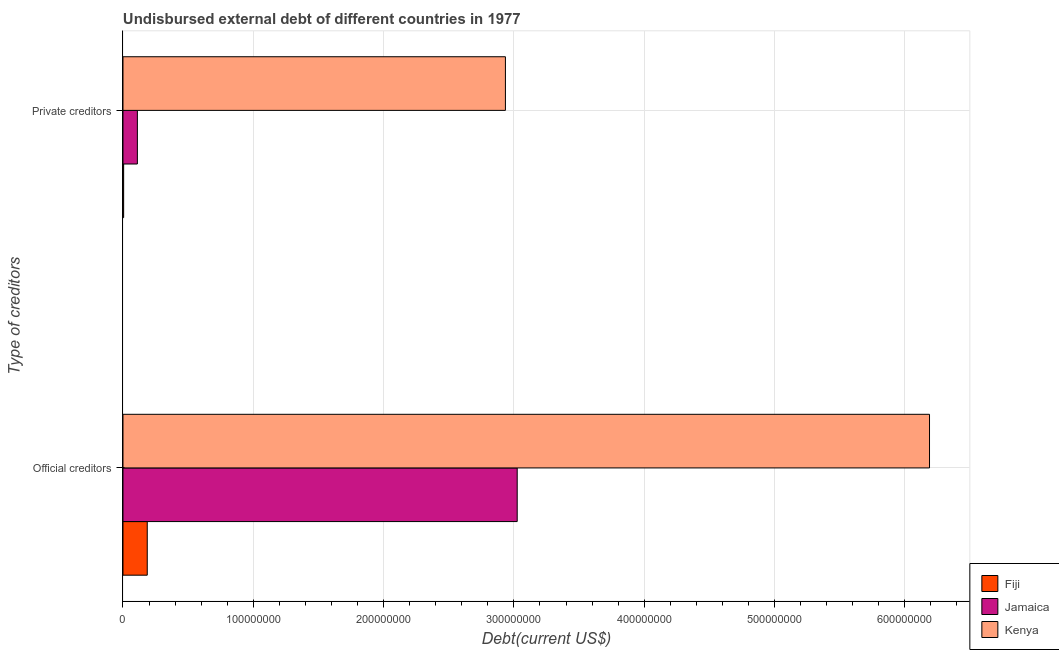How many different coloured bars are there?
Make the answer very short. 3. Are the number of bars per tick equal to the number of legend labels?
Offer a terse response. Yes. What is the label of the 1st group of bars from the top?
Make the answer very short. Private creditors. What is the undisbursed external debt of official creditors in Jamaica?
Make the answer very short. 3.03e+08. Across all countries, what is the maximum undisbursed external debt of official creditors?
Your answer should be very brief. 6.19e+08. Across all countries, what is the minimum undisbursed external debt of official creditors?
Your answer should be compact. 1.86e+07. In which country was the undisbursed external debt of private creditors maximum?
Provide a short and direct response. Kenya. In which country was the undisbursed external debt of private creditors minimum?
Make the answer very short. Fiji. What is the total undisbursed external debt of private creditors in the graph?
Your response must be concise. 3.05e+08. What is the difference between the undisbursed external debt of private creditors in Fiji and that in Kenya?
Offer a terse response. -2.93e+08. What is the difference between the undisbursed external debt of private creditors in Fiji and the undisbursed external debt of official creditors in Jamaica?
Keep it short and to the point. -3.02e+08. What is the average undisbursed external debt of official creditors per country?
Offer a very short reply. 3.13e+08. What is the difference between the undisbursed external debt of private creditors and undisbursed external debt of official creditors in Kenya?
Make the answer very short. -3.25e+08. What is the ratio of the undisbursed external debt of private creditors in Fiji to that in Kenya?
Make the answer very short. 0. Is the undisbursed external debt of private creditors in Fiji less than that in Jamaica?
Offer a very short reply. Yes. In how many countries, is the undisbursed external debt of private creditors greater than the average undisbursed external debt of private creditors taken over all countries?
Your answer should be compact. 1. What does the 1st bar from the top in Official creditors represents?
Make the answer very short. Kenya. What does the 3rd bar from the bottom in Official creditors represents?
Your response must be concise. Kenya. How many bars are there?
Provide a succinct answer. 6. Are all the bars in the graph horizontal?
Keep it short and to the point. Yes. What is the difference between two consecutive major ticks on the X-axis?
Your answer should be compact. 1.00e+08. Does the graph contain grids?
Give a very brief answer. Yes. How are the legend labels stacked?
Provide a succinct answer. Vertical. What is the title of the graph?
Keep it short and to the point. Undisbursed external debt of different countries in 1977. Does "Portugal" appear as one of the legend labels in the graph?
Provide a short and direct response. No. What is the label or title of the X-axis?
Your response must be concise. Debt(current US$). What is the label or title of the Y-axis?
Ensure brevity in your answer.  Type of creditors. What is the Debt(current US$) in Fiji in Official creditors?
Offer a very short reply. 1.86e+07. What is the Debt(current US$) of Jamaica in Official creditors?
Provide a short and direct response. 3.03e+08. What is the Debt(current US$) in Kenya in Official creditors?
Your answer should be compact. 6.19e+08. What is the Debt(current US$) of Fiji in Private creditors?
Make the answer very short. 5.07e+05. What is the Debt(current US$) in Jamaica in Private creditors?
Your answer should be compact. 1.10e+07. What is the Debt(current US$) in Kenya in Private creditors?
Provide a short and direct response. 2.93e+08. Across all Type of creditors, what is the maximum Debt(current US$) in Fiji?
Offer a very short reply. 1.86e+07. Across all Type of creditors, what is the maximum Debt(current US$) of Jamaica?
Provide a succinct answer. 3.03e+08. Across all Type of creditors, what is the maximum Debt(current US$) of Kenya?
Give a very brief answer. 6.19e+08. Across all Type of creditors, what is the minimum Debt(current US$) of Fiji?
Ensure brevity in your answer.  5.07e+05. Across all Type of creditors, what is the minimum Debt(current US$) in Jamaica?
Keep it short and to the point. 1.10e+07. Across all Type of creditors, what is the minimum Debt(current US$) in Kenya?
Give a very brief answer. 2.93e+08. What is the total Debt(current US$) in Fiji in the graph?
Provide a succinct answer. 1.91e+07. What is the total Debt(current US$) in Jamaica in the graph?
Your answer should be compact. 3.14e+08. What is the total Debt(current US$) of Kenya in the graph?
Your response must be concise. 9.12e+08. What is the difference between the Debt(current US$) in Fiji in Official creditors and that in Private creditors?
Ensure brevity in your answer.  1.81e+07. What is the difference between the Debt(current US$) of Jamaica in Official creditors and that in Private creditors?
Offer a terse response. 2.91e+08. What is the difference between the Debt(current US$) in Kenya in Official creditors and that in Private creditors?
Your answer should be compact. 3.25e+08. What is the difference between the Debt(current US$) of Fiji in Official creditors and the Debt(current US$) of Jamaica in Private creditors?
Provide a succinct answer. 7.58e+06. What is the difference between the Debt(current US$) in Fiji in Official creditors and the Debt(current US$) in Kenya in Private creditors?
Give a very brief answer. -2.75e+08. What is the difference between the Debt(current US$) of Jamaica in Official creditors and the Debt(current US$) of Kenya in Private creditors?
Give a very brief answer. 9.04e+06. What is the average Debt(current US$) of Fiji per Type of creditors?
Your answer should be very brief. 9.57e+06. What is the average Debt(current US$) of Jamaica per Type of creditors?
Keep it short and to the point. 1.57e+08. What is the average Debt(current US$) of Kenya per Type of creditors?
Your response must be concise. 4.56e+08. What is the difference between the Debt(current US$) in Fiji and Debt(current US$) in Jamaica in Official creditors?
Offer a terse response. -2.84e+08. What is the difference between the Debt(current US$) of Fiji and Debt(current US$) of Kenya in Official creditors?
Provide a succinct answer. -6.00e+08. What is the difference between the Debt(current US$) in Jamaica and Debt(current US$) in Kenya in Official creditors?
Provide a short and direct response. -3.16e+08. What is the difference between the Debt(current US$) of Fiji and Debt(current US$) of Jamaica in Private creditors?
Provide a succinct answer. -1.05e+07. What is the difference between the Debt(current US$) in Fiji and Debt(current US$) in Kenya in Private creditors?
Offer a terse response. -2.93e+08. What is the difference between the Debt(current US$) in Jamaica and Debt(current US$) in Kenya in Private creditors?
Give a very brief answer. -2.82e+08. What is the ratio of the Debt(current US$) of Fiji in Official creditors to that in Private creditors?
Make the answer very short. 36.74. What is the ratio of the Debt(current US$) in Jamaica in Official creditors to that in Private creditors?
Give a very brief answer. 27.38. What is the ratio of the Debt(current US$) in Kenya in Official creditors to that in Private creditors?
Ensure brevity in your answer.  2.11. What is the difference between the highest and the second highest Debt(current US$) in Fiji?
Keep it short and to the point. 1.81e+07. What is the difference between the highest and the second highest Debt(current US$) in Jamaica?
Offer a very short reply. 2.91e+08. What is the difference between the highest and the second highest Debt(current US$) of Kenya?
Ensure brevity in your answer.  3.25e+08. What is the difference between the highest and the lowest Debt(current US$) in Fiji?
Your response must be concise. 1.81e+07. What is the difference between the highest and the lowest Debt(current US$) in Jamaica?
Provide a succinct answer. 2.91e+08. What is the difference between the highest and the lowest Debt(current US$) of Kenya?
Your answer should be very brief. 3.25e+08. 